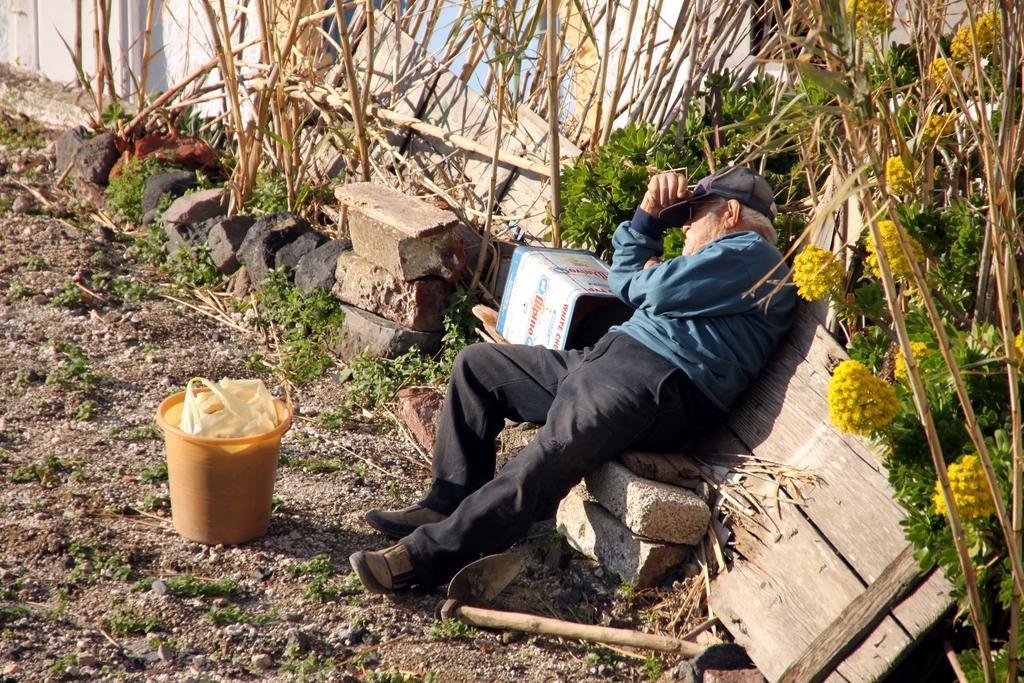Please provide a concise description of this image. In this image I can see the ground, some grass and an orange colored bucket on the ground. I can see a person wearing blue and black colored dress is sitting, few bricks and few trees which are brown and green in color. I can see few flowers which are yellow in color. 